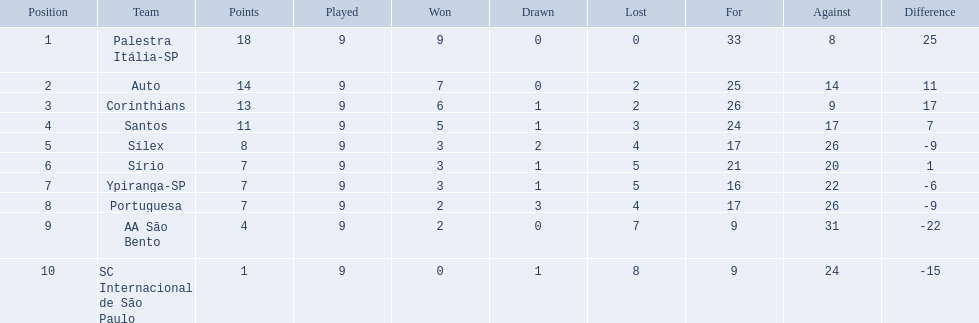How many football teams were involved in the 1926 brazilian season? Palestra Itália-SP, Auto, Corinthians, Santos, Sílex, Sírio, Ypiranga-SP, Portuguesa, AA São Bento, SC Internacional de São Paulo. What was the highest number of games won by a team during that season? 9. In the 1926 season, which team held the top position with 9 victories? Palestra Itália-SP. 